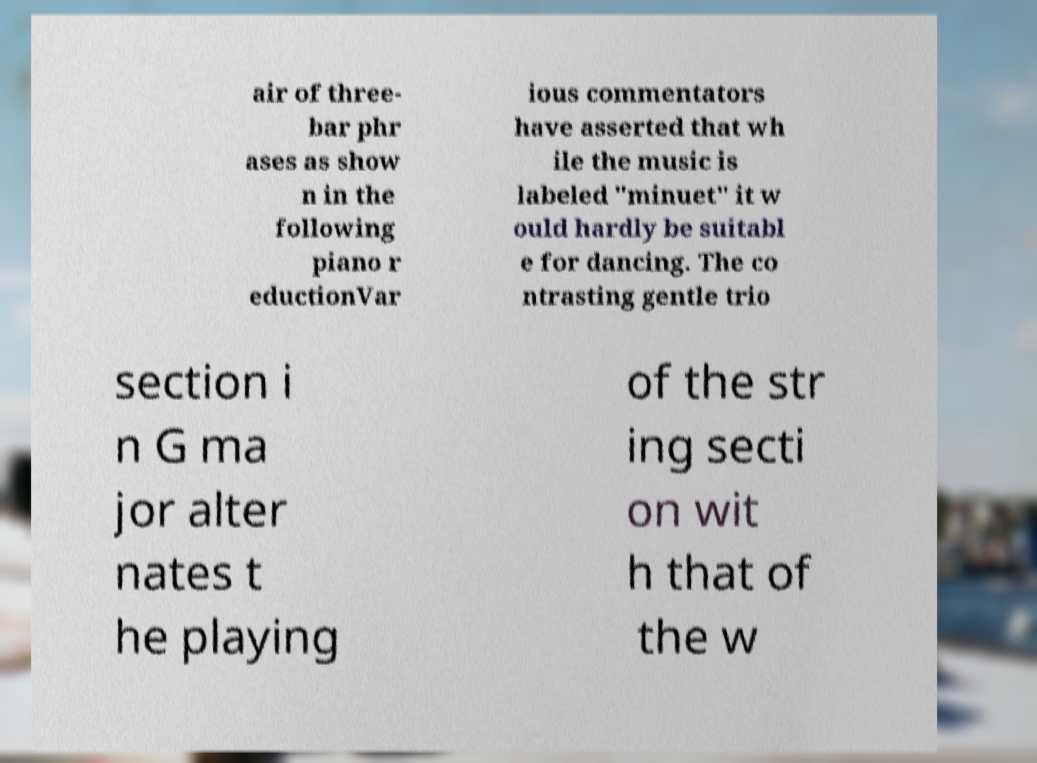Can you accurately transcribe the text from the provided image for me? air of three- bar phr ases as show n in the following piano r eductionVar ious commentators have asserted that wh ile the music is labeled "minuet" it w ould hardly be suitabl e for dancing. The co ntrasting gentle trio section i n G ma jor alter nates t he playing of the str ing secti on wit h that of the w 